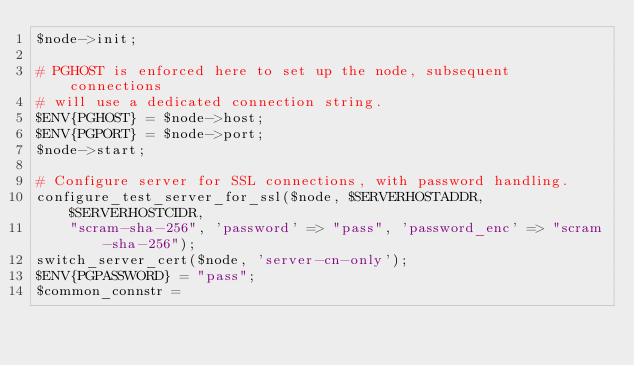<code> <loc_0><loc_0><loc_500><loc_500><_Perl_>$node->init;

# PGHOST is enforced here to set up the node, subsequent connections
# will use a dedicated connection string.
$ENV{PGHOST} = $node->host;
$ENV{PGPORT} = $node->port;
$node->start;

# Configure server for SSL connections, with password handling.
configure_test_server_for_ssl($node, $SERVERHOSTADDR, $SERVERHOSTCIDR,
	"scram-sha-256", 'password' => "pass", 'password_enc' => "scram-sha-256");
switch_server_cert($node, 'server-cn-only');
$ENV{PGPASSWORD} = "pass";
$common_connstr =</code> 